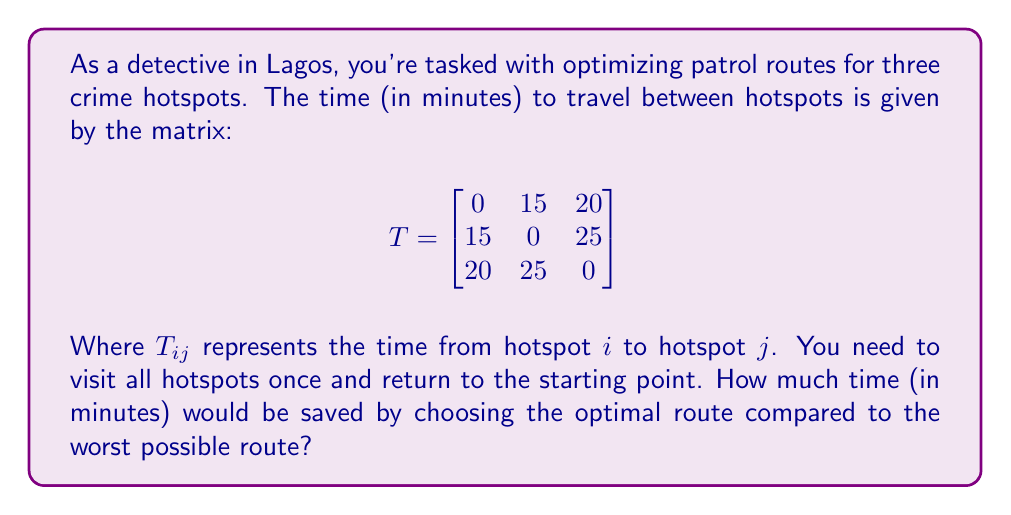Solve this math problem. To solve this problem, we need to consider all possible routes and compare their total times:

1) First, let's list all possible routes:
   1-2-3-1, 1-3-2-1, 2-1-3-2, 2-3-1-2, 3-1-2-3, 3-2-1-3

2) Now, let's calculate the time for each route:

   1-2-3-1: 15 + 25 + 20 = 60 minutes
   1-3-2-1: 20 + 25 + 15 = 60 minutes
   2-1-3-2: 15 + 20 + 25 = 60 minutes
   2-3-1-2: 25 + 20 + 15 = 60 minutes
   3-1-2-3: 20 + 15 + 25 = 60 minutes
   3-2-1-3: 25 + 15 + 20 = 60 minutes

3) We can see that all routes take the same amount of time: 60 minutes.

4) This is because the matrix is symmetric ($T_{ij} = T_{ji}$), which means the time from A to B is the same as from B to A for all hotspots.

5) In this case, there is no difference between the optimal route and the worst possible route, as they all take the same time.

Therefore, the time saved by choosing the optimal route compared to the worst possible route is 0 minutes.
Answer: 0 minutes 